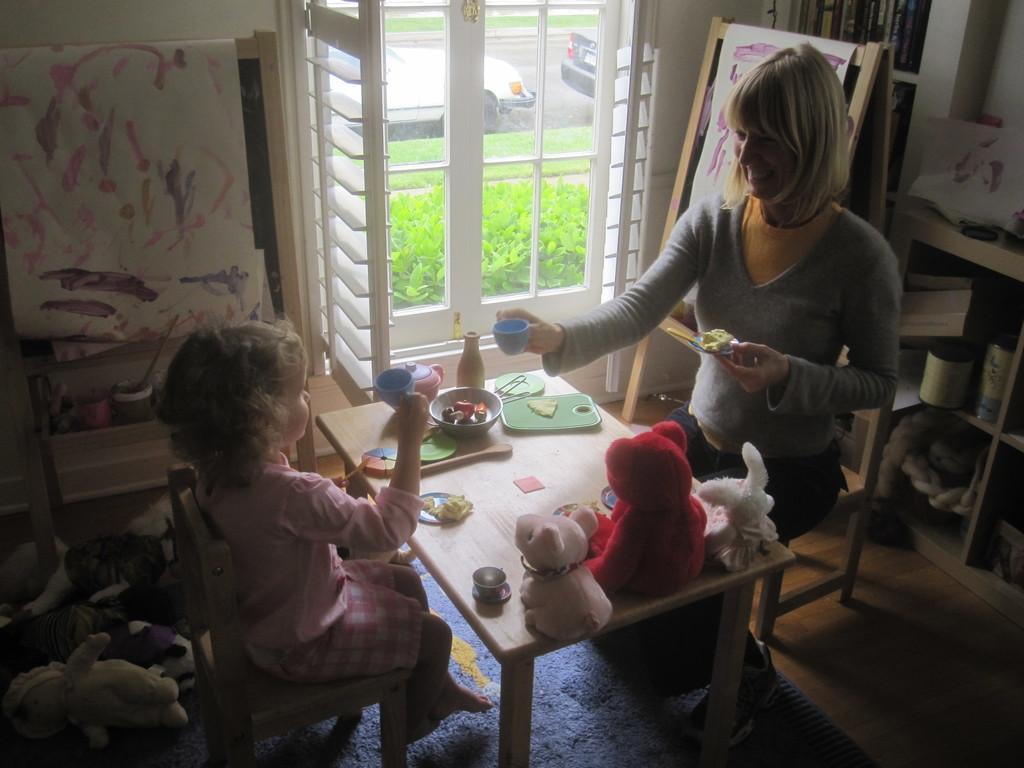How would you summarize this image in a sentence or two? In the image we can see there is a woman who is sitting on chair and there is a little girl who is sitting in front of her hand on table there are toys and in a bowl there are toy food items and noodles in a plate and a cup. 